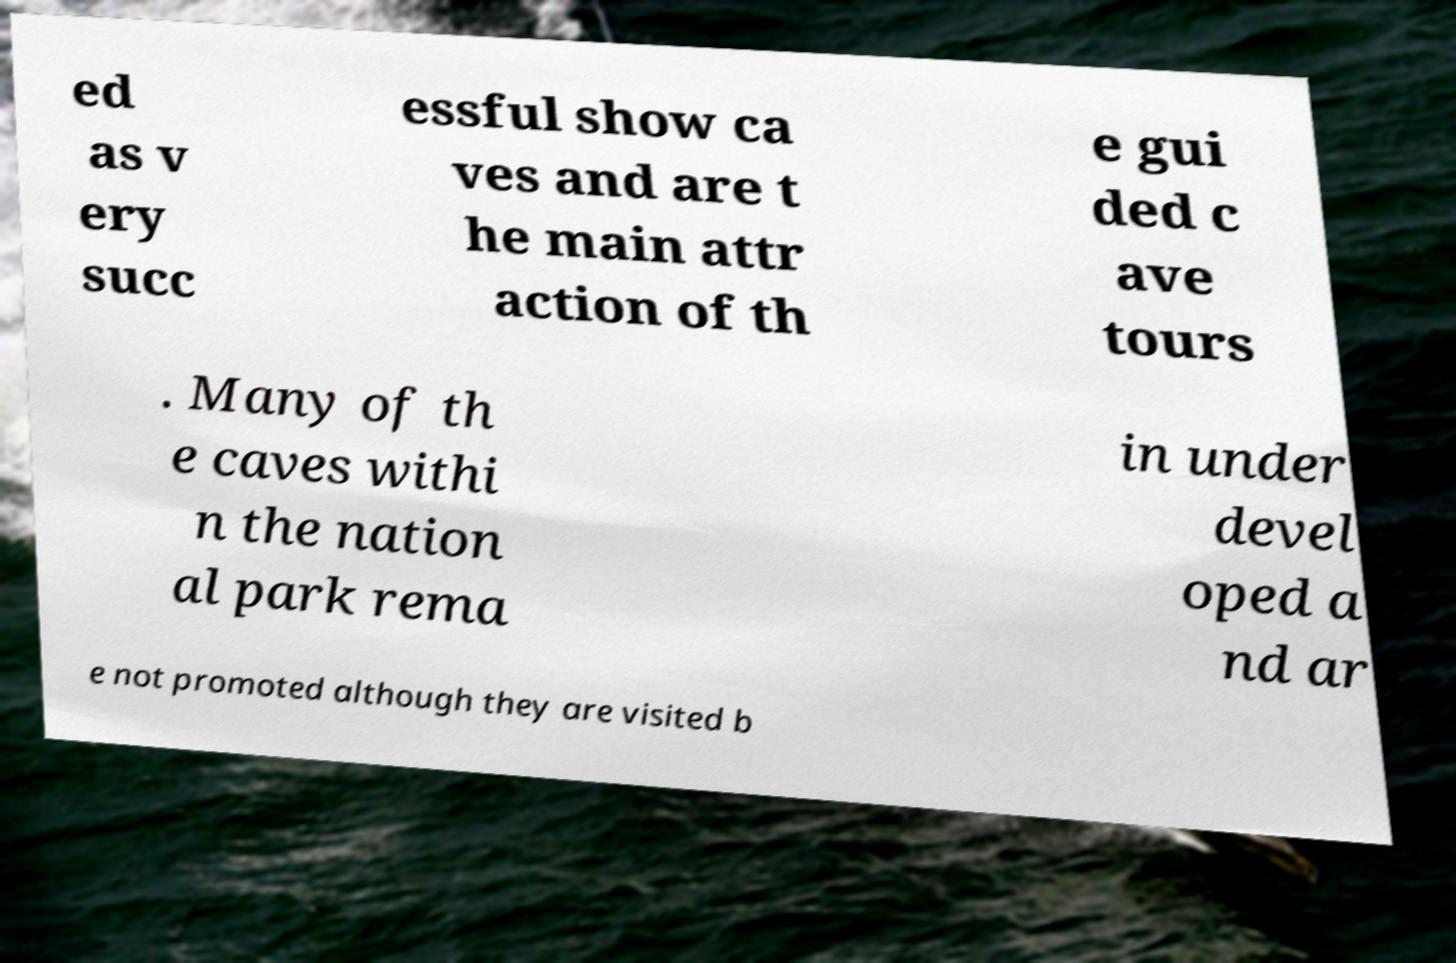Could you extract and type out the text from this image? ed as v ery succ essful show ca ves and are t he main attr action of th e gui ded c ave tours . Many of th e caves withi n the nation al park rema in under devel oped a nd ar e not promoted although they are visited b 